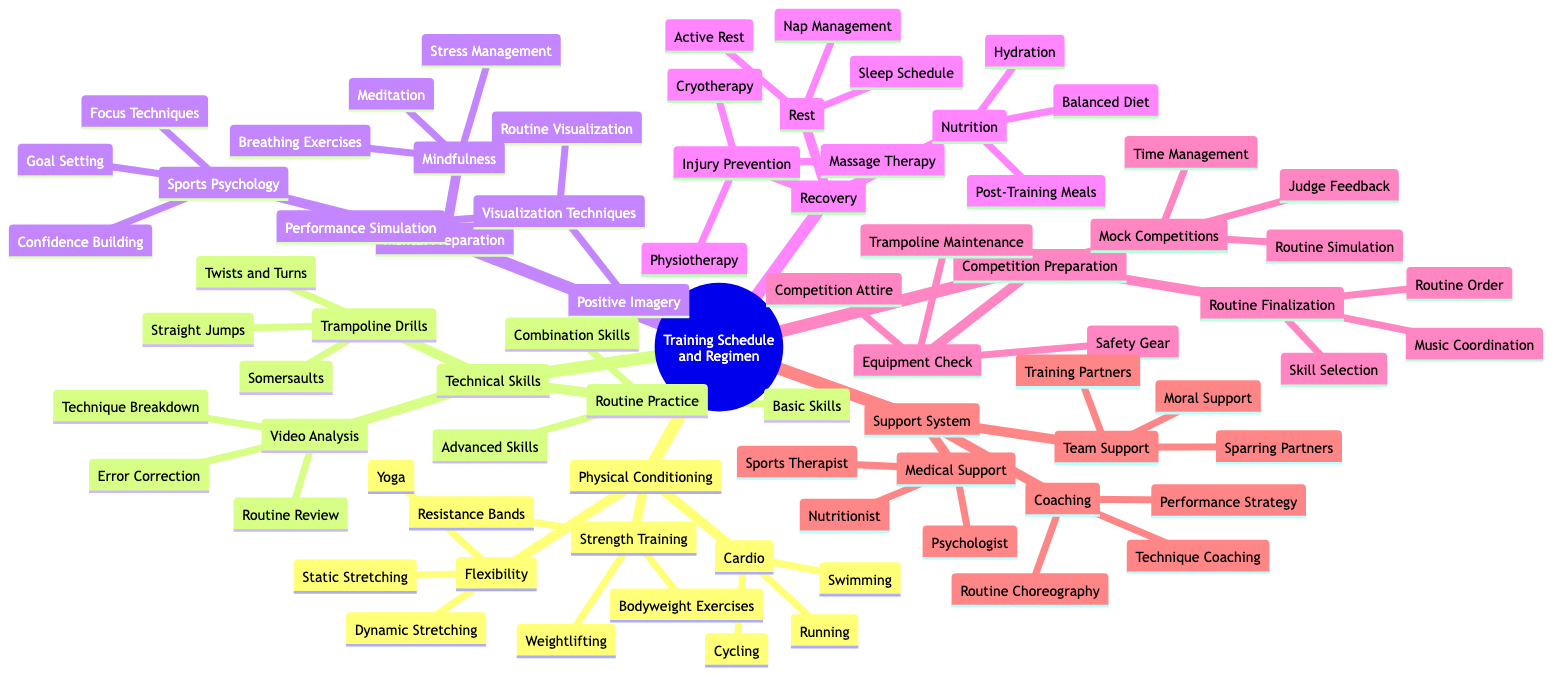What are the three main components of physical conditioning? The first level of the diagram under "Physical Conditioning" lists three sub-components: "Cardio," "Strength Training," and "Flexibility." These are the main areas of focus for physical conditioning.
Answer: Cardio, Strength Training, Flexibility How many types of mental preparation techniques are mentioned? Under the "Mental Preparation" section, there are three distinct categories: "Visualization Techniques," "Mindfulness," and "Sports Psychology." This total counts to three types of mental preparation techniques.
Answer: 3 Which category includes "Mock Competitions"? The "Mock Competitions" belong to the category "Competition Preparation." By following the path from the root node, one can see that this sub-item is directly nested under the main category for preparing for competitions.
Answer: Competition Preparation List one type of recovery method related to nutrition. Under the "Recovery" section, there is a subcategory for "Nutrition," which lists three specific methods including "Balanced Diet," "Hydration," and "Post-Training Meals." Any of these can answer the question.
Answer: Balanced Diet What is the purpose of "Video Analysis" in technical skills? "Video Analysis" refers to a specific practice within "Technical Skills" aimed at improving performance through reviewing recorded routines. It can further break down into "Routine Review," "Technique Breakdown," and "Error Correction," all contributing to the improvement of technical skills.
Answer: Improve performance How many types of support are included in the support system? In the "Support System" section, there are three primary types mentioned: "Coaching," "Medical Support," and "Team Support." Each of these represents a distinct category of support that a gymnast can receive.
Answer: 3 What specific training partners can contribute to the support system? "Training Partners" is a sub-item listed under the "Team Support" category. This indicates that one of the types of support a gymnast can receive involves assistance from fellow athletes during training.
Answer: Training Partners Identify a flexibility training method listed in the diagram. Under "Physical Conditioning," in the "Flexibility" category, there are three options: "Yoga," "Dynamic Stretching," and "Static Stretching." Any of these methods allows athletes to work on flexibility.
Answer: Yoga 